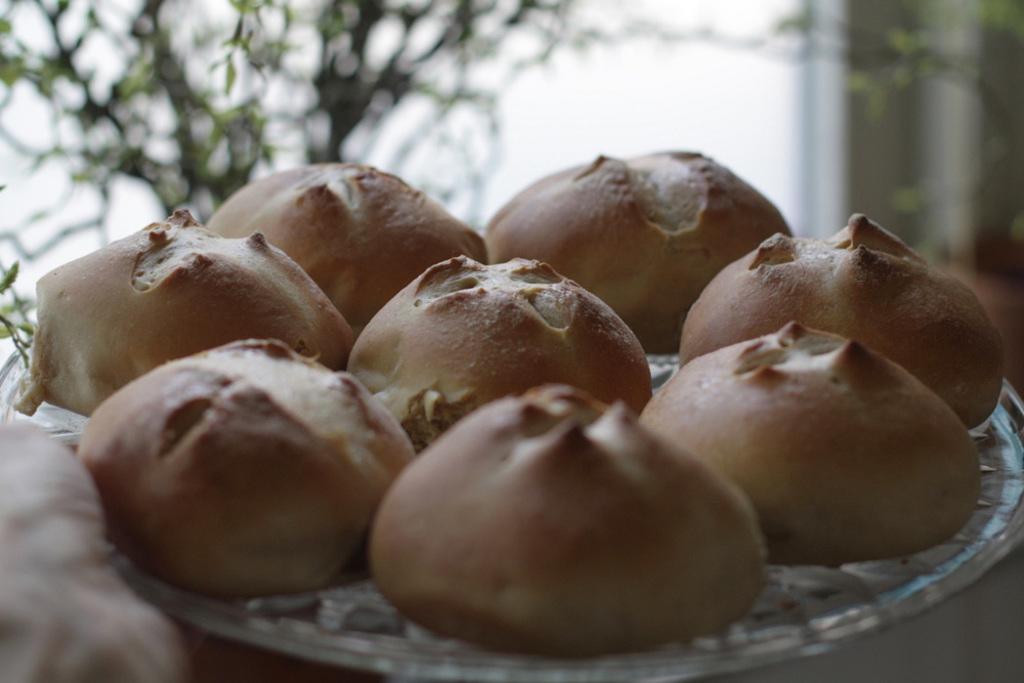Can you describe this image briefly? In this image there is a baked food item on the plate , and at the background there is a plant. 